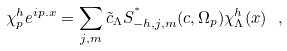<formula> <loc_0><loc_0><loc_500><loc_500>\chi _ { p } ^ { h } e ^ { i p . x } = \sum _ { j , m } \tilde { c } _ { \Lambda } S _ { - h , j , m } ^ { ^ { * } } ( c , \Omega _ { p } ) \chi _ { \Lambda } ^ { h } ( x ) \ ,</formula> 